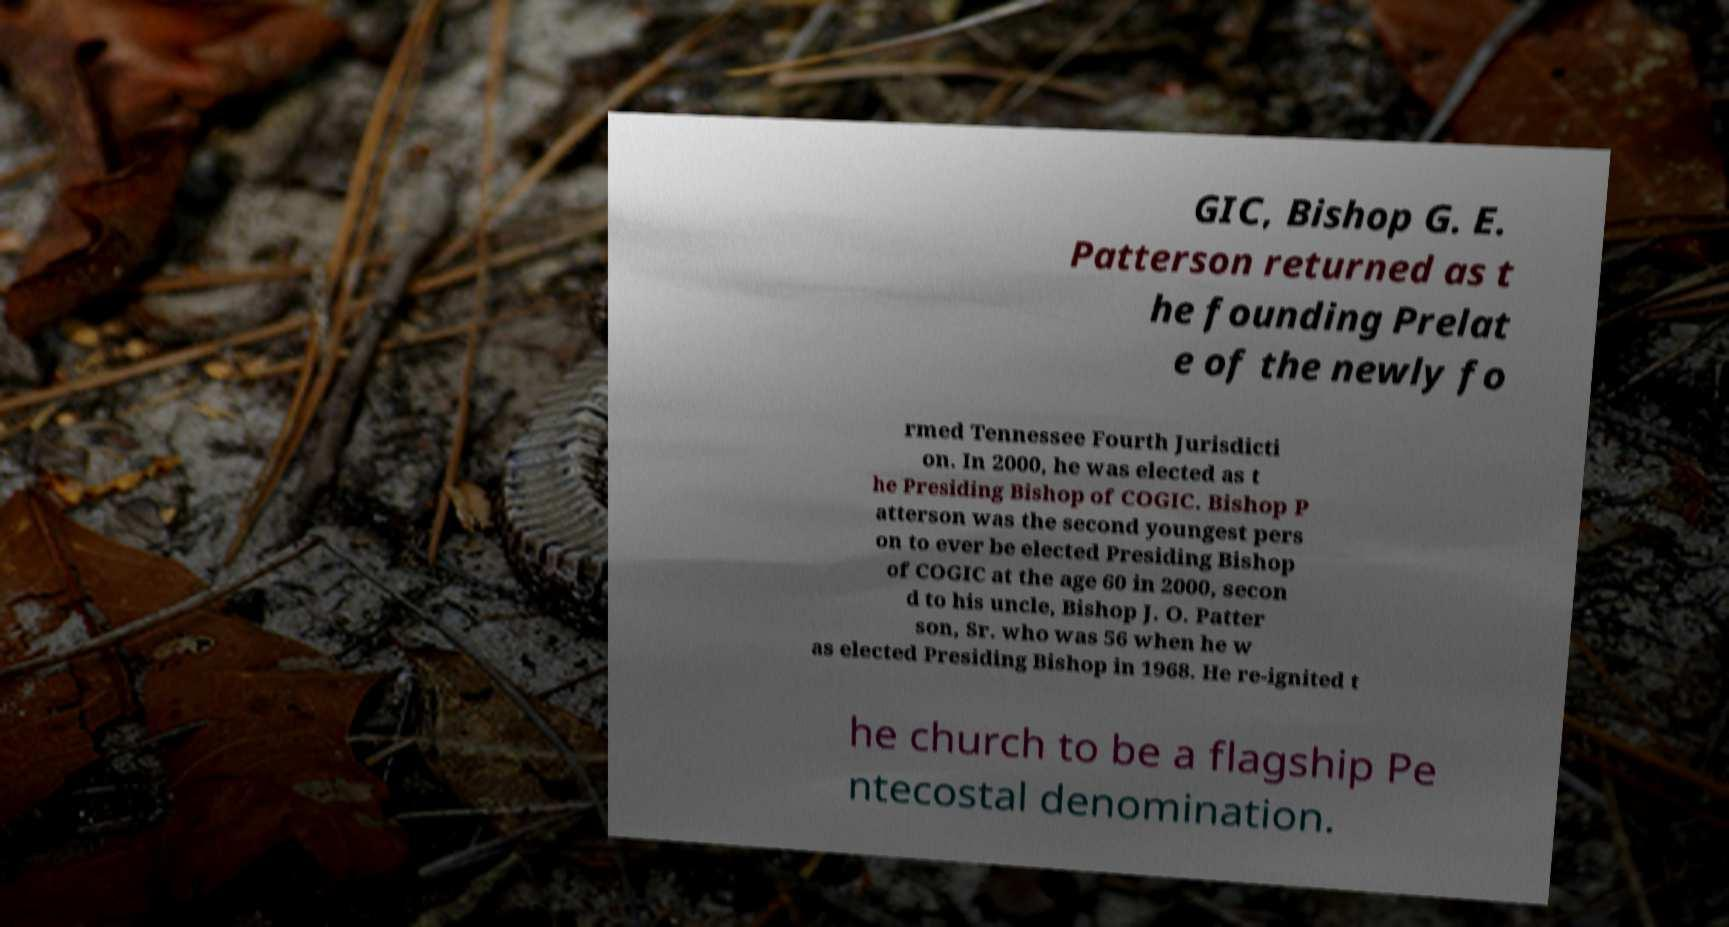What messages or text are displayed in this image? I need them in a readable, typed format. GIC, Bishop G. E. Patterson returned as t he founding Prelat e of the newly fo rmed Tennessee Fourth Jurisdicti on. In 2000, he was elected as t he Presiding Bishop of COGIC. Bishop P atterson was the second youngest pers on to ever be elected Presiding Bishop of COGIC at the age 60 in 2000, secon d to his uncle, Bishop J. O. Patter son, Sr. who was 56 when he w as elected Presiding Bishop in 1968. He re-ignited t he church to be a flagship Pe ntecostal denomination. 